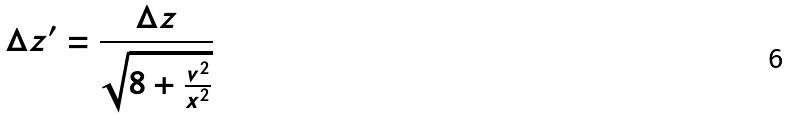<formula> <loc_0><loc_0><loc_500><loc_500>\Delta z ^ { \prime } = \frac { \Delta z } { \sqrt { 8 + \frac { v ^ { 2 } } { x ^ { 2 } } } }</formula> 